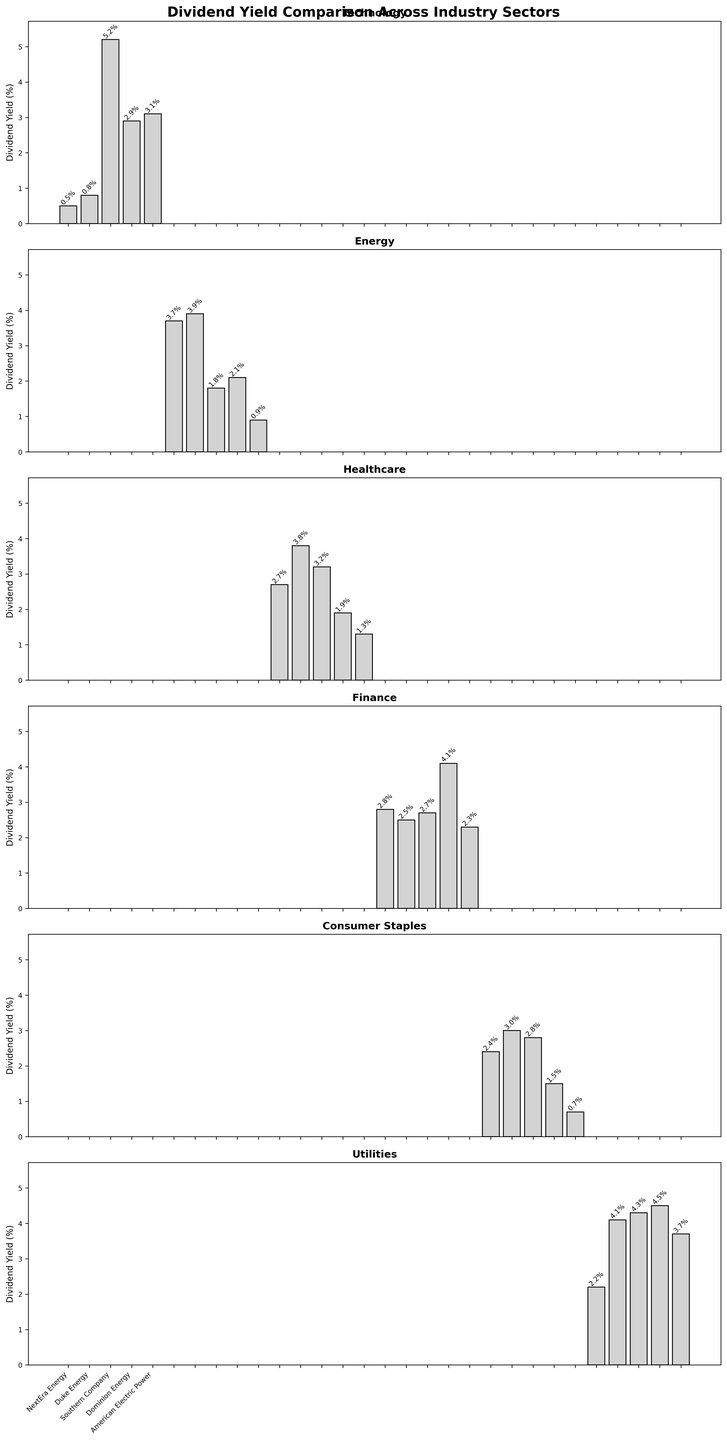Which sector has the highest average dividend yield? To find the sector with the highest average dividend yield, we need to calculate the average for each sector based on the individual yields shown in the figure. For example, we sum up the yields for the Healthcare sector and divide by the number of companies in that sector. After comparing the averages for all sectors, we find that the Utilities sector has the highest average dividend yield.
Answer: Utilities Which company within the Technology sector has the lowest dividend yield? Looking at the Technology sector subplot, the heights of the bars represent the dividend yields of each company. Apple has the lowest bar indicating the lowest dividend yield in this sector.
Answer: Apple Compare the dividend yields between the highest-yielding company in the Energy sector and the highest-yielding company in the Finance sector. Which one is higher? To determine this, we first identify the companies with the highest yields in the Energy and Finance sectors by looking at the tallest bars in their respective subplots. Chevron has the highest yield in the Energy sector (3.9%), while Citigroup has the highest in the Finance sector (4.1%). Comparing the two, Citigroup has the higher yield.
Answer: Citigroup What is the median dividend yield for the Consumer Staples sector? To find the median yield for the Consumer Staples sector, we need to list all the yields in ascending order: (0.7, 1.5, 2.4, 2.8, 3.0). Since there are an odd number of companies (5), the median is the third value in the list, which is 2.8%.
Answer: 2.8% Which sector shows the smallest range in dividend yields? The range is calculated by subtracting the smallest yield from the largest yield within each sector. Evaluating the subplots, the smallest range is in the Healthcare sector (3.8% - 1.3% = 2.5%).
Answer: Healthcare Does the highest dividend yield in the Healthcare sector exceed the lowest dividend yield in the Utilities sector? The highest yield in the Healthcare sector is Pfizer at 3.8%. The lowest yield in the Utilities sector is NextEra Energy at 2.2%. Comparing these values, 3.8% is indeed higher than 2.2%.
Answer: Yes What is the difference between the highest and lowest dividend yields in the Utilities sector? To find the difference, identify the highest and lowest yields in the Utilities sector. The highest is Dominion Energy at 4.5% and the lowest is NextEra Energy at 2.2%. The difference is 4.5% - 2.2% = 2.3%.
Answer: 2.3% How does Pfizer's dividend yield compare to the average dividend yield of the Technology sector? First, compute the average yield for the Technology sector by summing all the yields and dividing by the number of companies: (0.5 + 0.8 + 5.2 + 2.9 + 3.1) / 5 = 2.5%. Pfizer's yield is 3.8%, which is higher than the Technology sector average.
Answer: Higher 